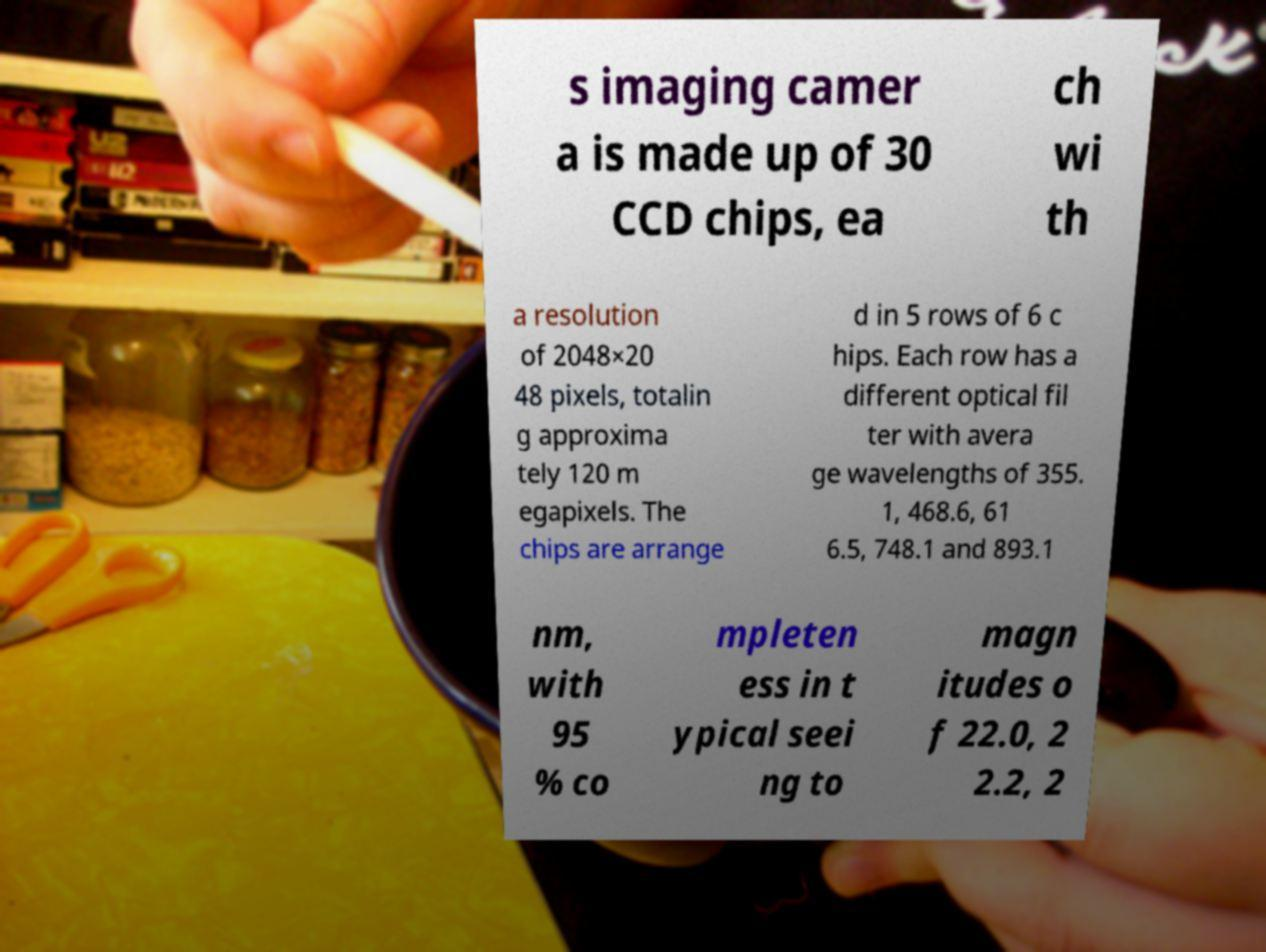Could you assist in decoding the text presented in this image and type it out clearly? s imaging camer a is made up of 30 CCD chips, ea ch wi th a resolution of 2048×20 48 pixels, totalin g approxima tely 120 m egapixels. The chips are arrange d in 5 rows of 6 c hips. Each row has a different optical fil ter with avera ge wavelengths of 355. 1, 468.6, 61 6.5, 748.1 and 893.1 nm, with 95 % co mpleten ess in t ypical seei ng to magn itudes o f 22.0, 2 2.2, 2 